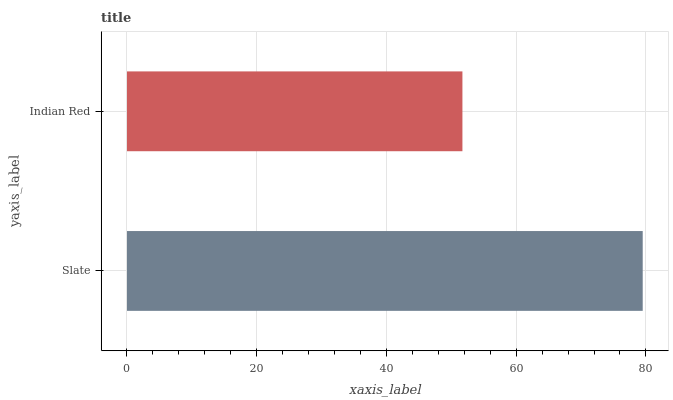Is Indian Red the minimum?
Answer yes or no. Yes. Is Slate the maximum?
Answer yes or no. Yes. Is Indian Red the maximum?
Answer yes or no. No. Is Slate greater than Indian Red?
Answer yes or no. Yes. Is Indian Red less than Slate?
Answer yes or no. Yes. Is Indian Red greater than Slate?
Answer yes or no. No. Is Slate less than Indian Red?
Answer yes or no. No. Is Slate the high median?
Answer yes or no. Yes. Is Indian Red the low median?
Answer yes or no. Yes. Is Indian Red the high median?
Answer yes or no. No. Is Slate the low median?
Answer yes or no. No. 